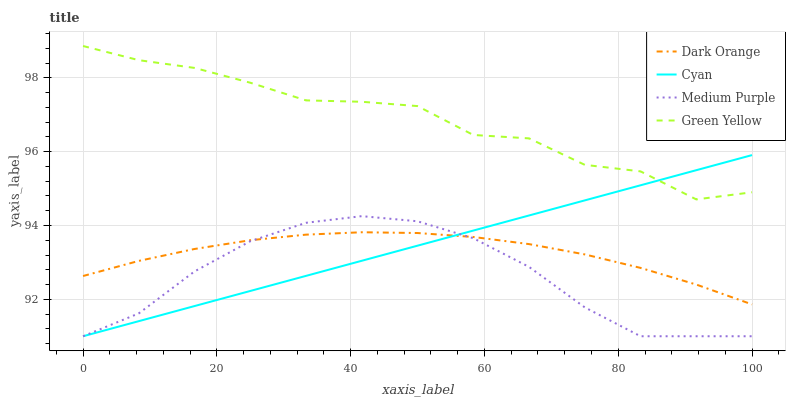Does Medium Purple have the minimum area under the curve?
Answer yes or no. Yes. Does Green Yellow have the maximum area under the curve?
Answer yes or no. Yes. Does Dark Orange have the minimum area under the curve?
Answer yes or no. No. Does Dark Orange have the maximum area under the curve?
Answer yes or no. No. Is Cyan the smoothest?
Answer yes or no. Yes. Is Green Yellow the roughest?
Answer yes or no. Yes. Is Dark Orange the smoothest?
Answer yes or no. No. Is Dark Orange the roughest?
Answer yes or no. No. Does Medium Purple have the lowest value?
Answer yes or no. Yes. Does Dark Orange have the lowest value?
Answer yes or no. No. Does Green Yellow have the highest value?
Answer yes or no. Yes. Does Dark Orange have the highest value?
Answer yes or no. No. Is Dark Orange less than Green Yellow?
Answer yes or no. Yes. Is Green Yellow greater than Medium Purple?
Answer yes or no. Yes. Does Cyan intersect Dark Orange?
Answer yes or no. Yes. Is Cyan less than Dark Orange?
Answer yes or no. No. Is Cyan greater than Dark Orange?
Answer yes or no. No. Does Dark Orange intersect Green Yellow?
Answer yes or no. No. 